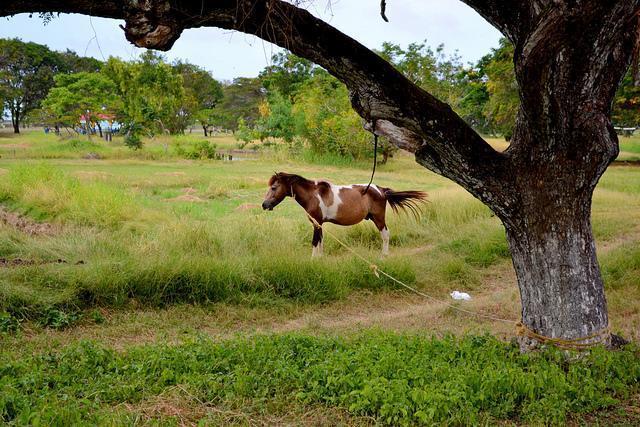How many trees are in the foreground?
Give a very brief answer. 1. 